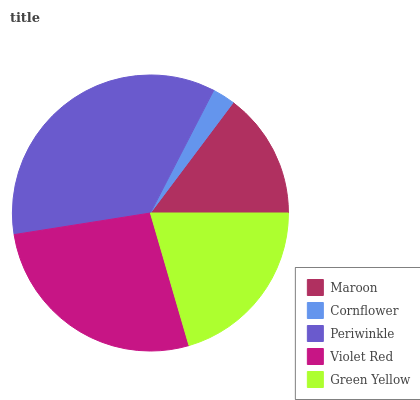Is Cornflower the minimum?
Answer yes or no. Yes. Is Periwinkle the maximum?
Answer yes or no. Yes. Is Periwinkle the minimum?
Answer yes or no. No. Is Cornflower the maximum?
Answer yes or no. No. Is Periwinkle greater than Cornflower?
Answer yes or no. Yes. Is Cornflower less than Periwinkle?
Answer yes or no. Yes. Is Cornflower greater than Periwinkle?
Answer yes or no. No. Is Periwinkle less than Cornflower?
Answer yes or no. No. Is Green Yellow the high median?
Answer yes or no. Yes. Is Green Yellow the low median?
Answer yes or no. Yes. Is Violet Red the high median?
Answer yes or no. No. Is Periwinkle the low median?
Answer yes or no. No. 